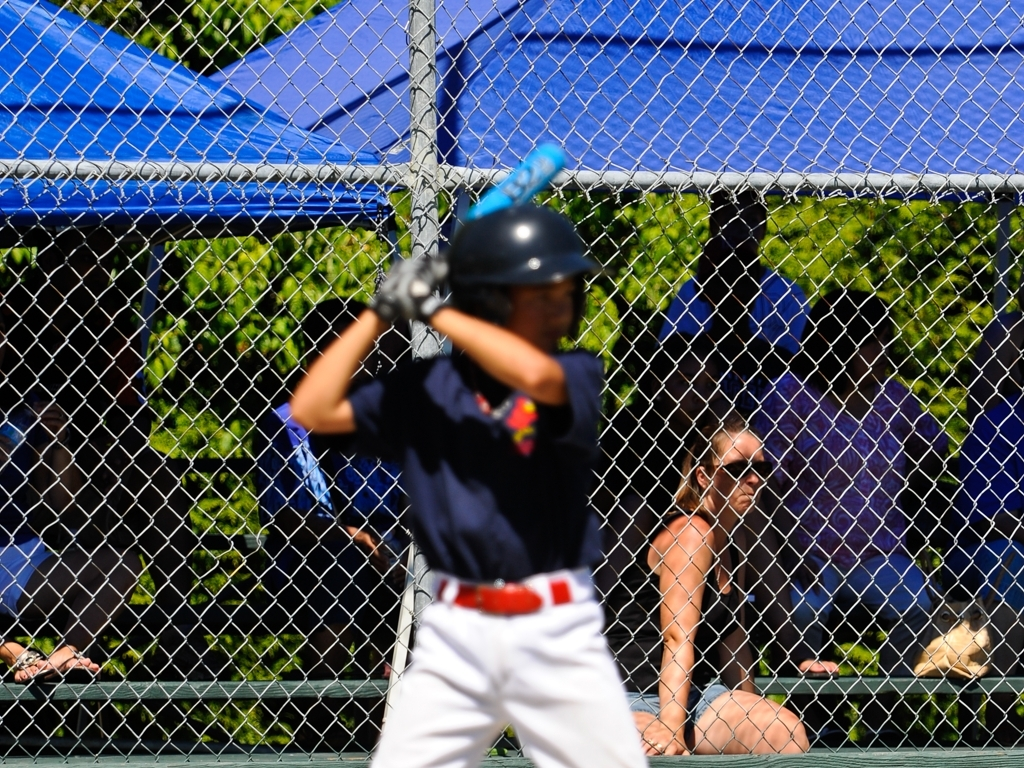What emotions might the blurred figure be experiencing in this moment? Based on the context of the image, which captures a baseball game in progress, the blurred figure is likely experiencing heightened emotions such as concentration, anticipation, and possibly excitement or nervousness, as they are either in the midst of swinging the bat or preparing for it. 